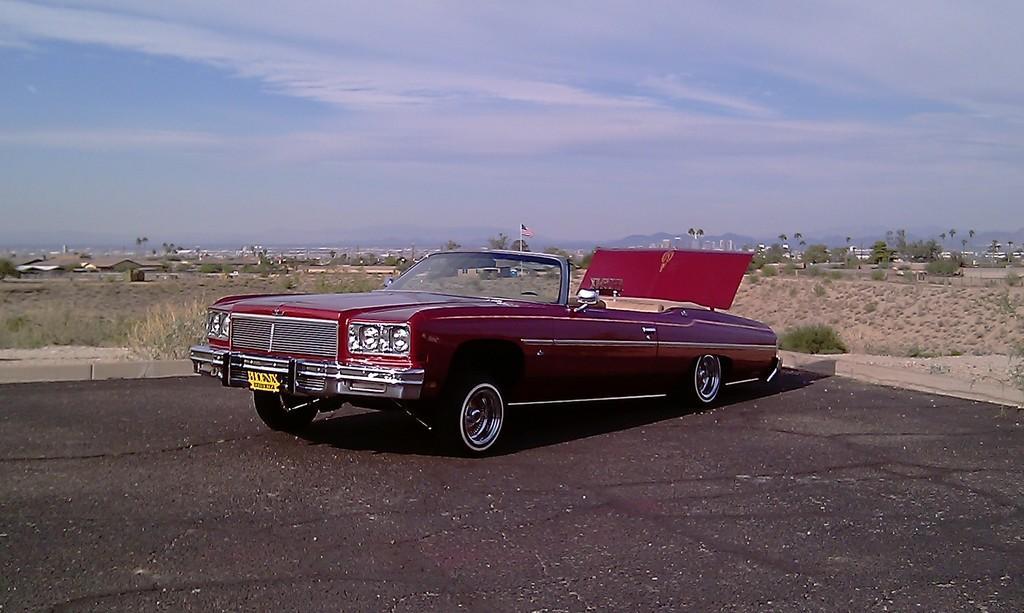Describe this image in one or two sentences. In this picture, we can see vehicle, poles, flag, road, ground, plants, trees, buildings, mountains, and the sky with clouds. 